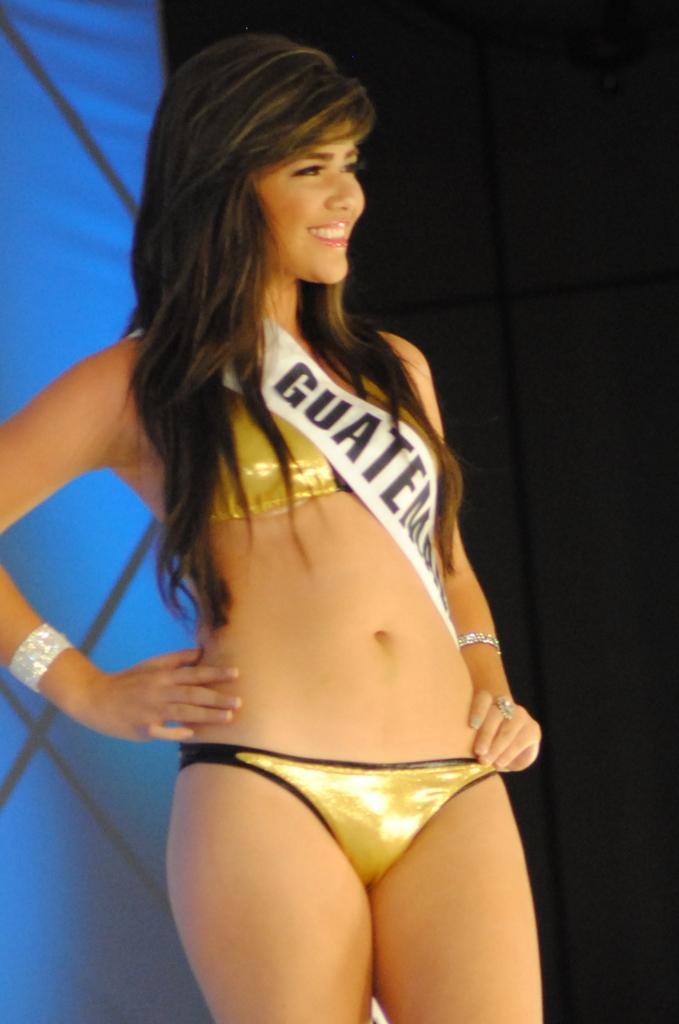How would you summarize this image in a sentence or two? In the image I can see a woman is standing and smiling. The woman is wearing a bikini and some other objects. 